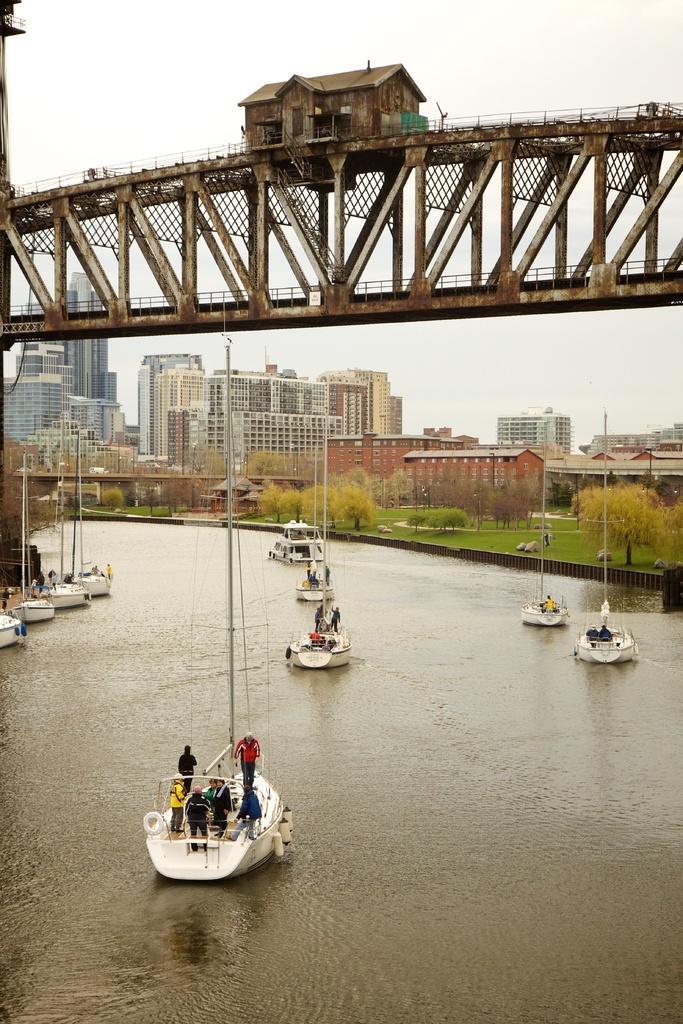How would you summarize this image in a sentence or two? In this image, we can see some water. There are a few ships with people sailing on the water. We can see the ground. We can see some grass, plants and trees. We can see some poles. There are a few buildings. We can see a bridge and a house on it. We can see the sky. 